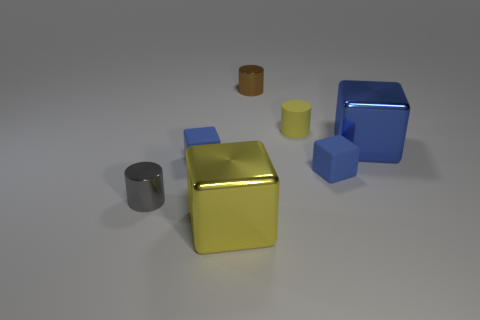Is the large yellow thing made of the same material as the tiny yellow cylinder that is behind the big blue metallic thing?
Provide a short and direct response. No. What number of things are gray objects or blue blocks?
Provide a succinct answer. 4. Are any small purple metal cylinders visible?
Offer a very short reply. No. What shape is the big thing that is on the right side of the thing that is in front of the gray object?
Keep it short and to the point. Cube. What number of things are small metal things that are behind the gray object or things on the right side of the brown metal cylinder?
Offer a terse response. 4. There is a yellow cylinder that is the same size as the brown cylinder; what is it made of?
Keep it short and to the point. Rubber. What color is the tiny matte cylinder?
Keep it short and to the point. Yellow. What is the material of the blue block that is both to the left of the blue metallic block and on the right side of the brown metal cylinder?
Offer a terse response. Rubber. Is there a brown metal thing in front of the small yellow object behind the large shiny block that is to the left of the big blue shiny cube?
Keep it short and to the point. No. What size is the thing that is the same color as the tiny matte cylinder?
Offer a terse response. Large. 